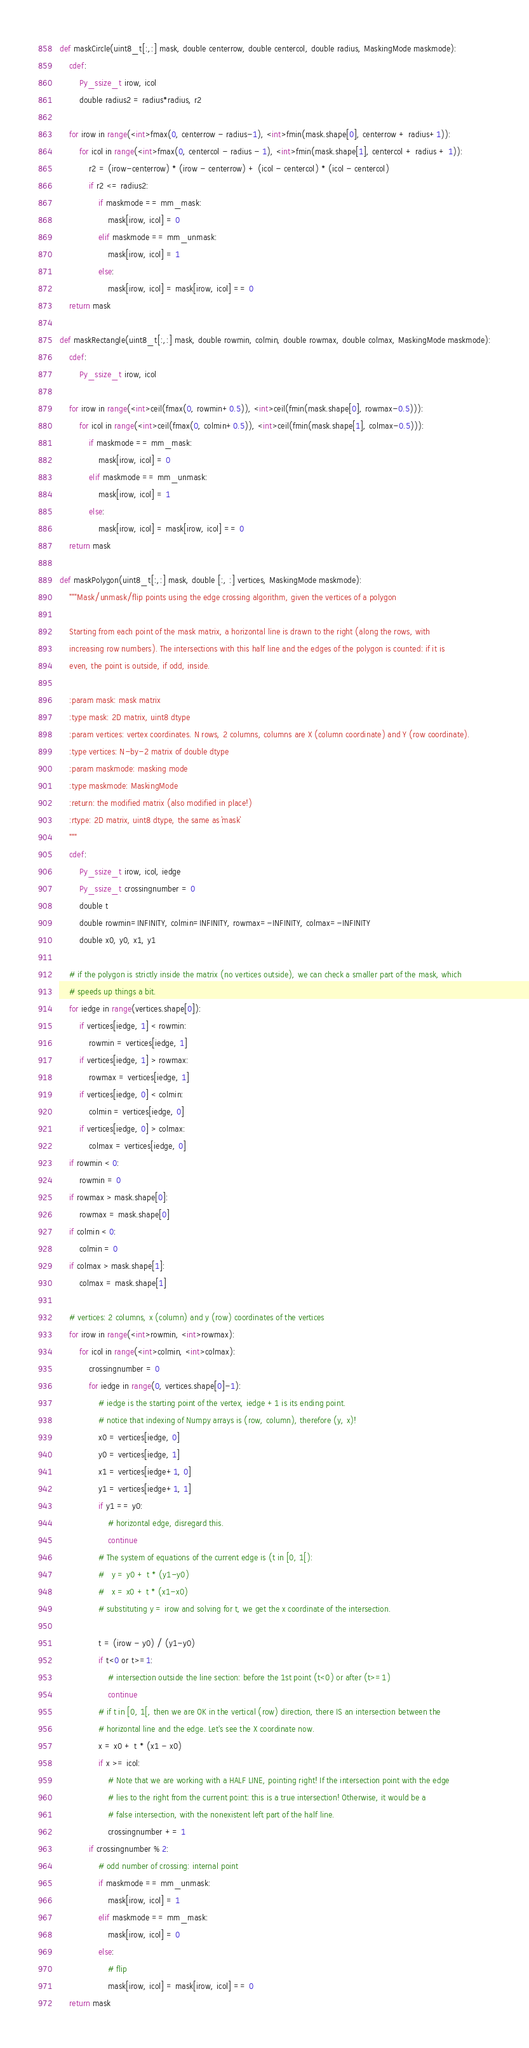Convert code to text. <code><loc_0><loc_0><loc_500><loc_500><_Cython_>

def maskCircle(uint8_t[:,:] mask, double centerrow, double centercol, double radius, MaskingMode maskmode):
    cdef:
        Py_ssize_t irow, icol
        double radius2 = radius*radius, r2

    for irow in range(<int>fmax(0, centerrow - radius-1), <int>fmin(mask.shape[0], centerrow + radius+1)):
        for icol in range(<int>fmax(0, centercol - radius - 1), <int>fmin(mask.shape[1], centercol + radius + 1)):
            r2 = (irow-centerrow) * (irow - centerrow) + (icol - centercol) * (icol - centercol)
            if r2 <= radius2:
                if maskmode == mm_mask:
                    mask[irow, icol] = 0
                elif maskmode == mm_unmask:
                    mask[irow, icol] = 1
                else:
                    mask[irow, icol] = mask[irow, icol] == 0
    return mask

def maskRectangle(uint8_t[:,:] mask, double rowmin, colmin, double rowmax, double colmax, MaskingMode maskmode):
    cdef:
        Py_ssize_t irow, icol

    for irow in range(<int>ceil(fmax(0, rowmin+0.5)), <int>ceil(fmin(mask.shape[0], rowmax-0.5))):
        for icol in range(<int>ceil(fmax(0, colmin+0.5)), <int>ceil(fmin(mask.shape[1], colmax-0.5))):
            if maskmode == mm_mask:
                mask[irow, icol] = 0
            elif maskmode == mm_unmask:
                mask[irow, icol] = 1
            else:
                mask[irow, icol] = mask[irow, icol] == 0
    return mask

def maskPolygon(uint8_t[:,:] mask, double [:, :] vertices, MaskingMode maskmode):
    """Mask/unmask/flip points using the edge crossing algorithm, given the vertices of a polygon

    Starting from each point of the mask matrix, a horizontal line is drawn to the right (along the rows, with
    increasing row numbers). The intersections with this half line and the edges of the polygon is counted: if it is
    even, the point is outside, if odd, inside.

    :param mask: mask matrix
    :type mask: 2D matrix, uint8 dtype
    :param vertices: vertex coordinates. N rows, 2 columns, columns are X (column coordinate) and Y (row coordinate).
    :type vertices: N-by-2 matrix of double dtype
    :param maskmode: masking mode
    :type maskmode: MaskingMode
    :return: the modified matrix (also modified in place!)
    :rtype: 2D matrix, uint8 dtype, the same as `mask`
    """
    cdef:
        Py_ssize_t irow, icol, iedge
        Py_ssize_t crossingnumber = 0
        double t
        double rowmin=INFINITY, colmin=INFINITY, rowmax=-INFINITY, colmax=-INFINITY
        double x0, y0, x1, y1

    # if the polygon is strictly inside the matrix (no vertices outside), we can check a smaller part of the mask, which
    # speeds up things a bit.
    for iedge in range(vertices.shape[0]):
        if vertices[iedge, 1] < rowmin:
            rowmin = vertices[iedge, 1]
        if vertices[iedge, 1] > rowmax:
            rowmax = vertices[iedge, 1]
        if vertices[iedge, 0] < colmin:
            colmin = vertices[iedge, 0]
        if vertices[iedge, 0] > colmax:
            colmax = vertices[iedge, 0]
    if rowmin < 0:
        rowmin = 0
    if rowmax > mask.shape[0]:
        rowmax = mask.shape[0]
    if colmin < 0:
        colmin = 0
    if colmax > mask.shape[1]:
        colmax = mask.shape[1]

    # vertices: 2 columns, x (column) and y (row) coordinates of the vertices
    for irow in range(<int>rowmin, <int>rowmax):
        for icol in range(<int>colmin, <int>colmax):
            crossingnumber = 0
            for iedge in range(0, vertices.shape[0]-1):
                # iedge is the starting point of the vertex, iedge +1 is its ending point.
                # notice that indexing of Numpy arrays is (row, column), therefore (y, x)!
                x0 = vertices[iedge, 0]
                y0 = vertices[iedge, 1]
                x1 = vertices[iedge+1, 0]
                y1 = vertices[iedge+1, 1]
                if y1 == y0:
                    # horizontal edge, disregard this.
                    continue
                # The system of equations of the current edge is (t in [0, 1[):
                #   y = y0 + t * (y1-y0)
                #   x = x0 + t * (x1-x0)
                # substituting y = irow and solving for t, we get the x coordinate of the intersection.

                t = (irow - y0) / (y1-y0)
                if t<0 or t>=1:
                    # intersection outside the line section: before the 1st point (t<0) or after (t>=1)
                    continue
                # if t in [0, 1[, then we are OK in the vertical (row) direction, there IS an intersection between the
                # horizontal line and the edge. Let's see the X coordinate now.
                x = x0 + t * (x1 - x0)
                if x >= icol:
                    # Note that we are working with a HALF LINE, pointing right! If the intersection point with the edge
                    # lies to the right from the current point: this is a true intersection! Otherwise, it would be a
                    # false intersection, with the nonexistent left part of the half line.
                    crossingnumber += 1
            if crossingnumber % 2:
                # odd number of crossing: internal point
                if maskmode == mm_unmask:
                    mask[irow, icol] = 1
                elif maskmode == mm_mask:
                    mask[irow, icol] = 0
                else:
                    # flip
                    mask[irow, icol] = mask[irow, icol] == 0
    return mask</code> 